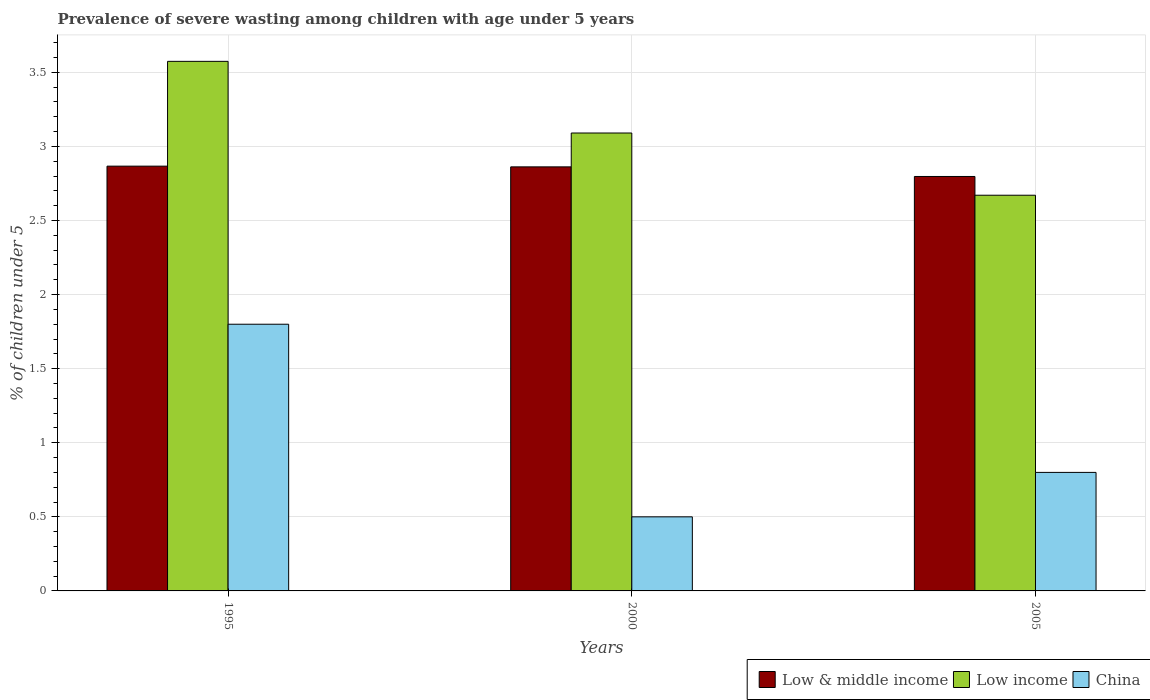How many different coloured bars are there?
Your answer should be very brief. 3. Are the number of bars per tick equal to the number of legend labels?
Give a very brief answer. Yes. Are the number of bars on each tick of the X-axis equal?
Offer a very short reply. Yes. What is the label of the 3rd group of bars from the left?
Offer a very short reply. 2005. What is the percentage of severely wasted children in China in 2005?
Give a very brief answer. 0.8. Across all years, what is the maximum percentage of severely wasted children in Low income?
Give a very brief answer. 3.57. Across all years, what is the minimum percentage of severely wasted children in Low & middle income?
Offer a very short reply. 2.8. What is the total percentage of severely wasted children in China in the graph?
Provide a short and direct response. 3.1. What is the difference between the percentage of severely wasted children in Low income in 1995 and that in 2005?
Your answer should be compact. 0.9. What is the difference between the percentage of severely wasted children in Low income in 2005 and the percentage of severely wasted children in Low & middle income in 1995?
Your response must be concise. -0.2. What is the average percentage of severely wasted children in Low & middle income per year?
Your answer should be compact. 2.84. In the year 1995, what is the difference between the percentage of severely wasted children in Low & middle income and percentage of severely wasted children in Low income?
Give a very brief answer. -0.71. In how many years, is the percentage of severely wasted children in Low income greater than 1.7 %?
Make the answer very short. 3. What is the ratio of the percentage of severely wasted children in China in 2000 to that in 2005?
Your answer should be very brief. 0.62. Is the percentage of severely wasted children in Low & middle income in 2000 less than that in 2005?
Keep it short and to the point. No. What is the difference between the highest and the second highest percentage of severely wasted children in Low & middle income?
Provide a short and direct response. 0. What is the difference between the highest and the lowest percentage of severely wasted children in Low & middle income?
Make the answer very short. 0.07. What does the 3rd bar from the left in 2005 represents?
Provide a succinct answer. China. Is it the case that in every year, the sum of the percentage of severely wasted children in Low & middle income and percentage of severely wasted children in Low income is greater than the percentage of severely wasted children in China?
Make the answer very short. Yes. Are the values on the major ticks of Y-axis written in scientific E-notation?
Your response must be concise. No. Does the graph contain any zero values?
Your response must be concise. No. Where does the legend appear in the graph?
Ensure brevity in your answer.  Bottom right. How many legend labels are there?
Offer a terse response. 3. What is the title of the graph?
Offer a very short reply. Prevalence of severe wasting among children with age under 5 years. Does "Norway" appear as one of the legend labels in the graph?
Keep it short and to the point. No. What is the label or title of the Y-axis?
Offer a very short reply. % of children under 5. What is the % of children under 5 in Low & middle income in 1995?
Your response must be concise. 2.87. What is the % of children under 5 of Low income in 1995?
Keep it short and to the point. 3.57. What is the % of children under 5 of China in 1995?
Give a very brief answer. 1.8. What is the % of children under 5 in Low & middle income in 2000?
Keep it short and to the point. 2.86. What is the % of children under 5 in Low income in 2000?
Keep it short and to the point. 3.09. What is the % of children under 5 in China in 2000?
Offer a terse response. 0.5. What is the % of children under 5 in Low & middle income in 2005?
Your answer should be compact. 2.8. What is the % of children under 5 in Low income in 2005?
Make the answer very short. 2.67. What is the % of children under 5 in China in 2005?
Keep it short and to the point. 0.8. Across all years, what is the maximum % of children under 5 of Low & middle income?
Offer a terse response. 2.87. Across all years, what is the maximum % of children under 5 of Low income?
Your answer should be very brief. 3.57. Across all years, what is the maximum % of children under 5 of China?
Provide a short and direct response. 1.8. Across all years, what is the minimum % of children under 5 in Low & middle income?
Your answer should be very brief. 2.8. Across all years, what is the minimum % of children under 5 of Low income?
Ensure brevity in your answer.  2.67. What is the total % of children under 5 of Low & middle income in the graph?
Ensure brevity in your answer.  8.53. What is the total % of children under 5 in Low income in the graph?
Offer a terse response. 9.34. What is the difference between the % of children under 5 in Low & middle income in 1995 and that in 2000?
Keep it short and to the point. 0. What is the difference between the % of children under 5 of Low income in 1995 and that in 2000?
Provide a succinct answer. 0.48. What is the difference between the % of children under 5 in China in 1995 and that in 2000?
Make the answer very short. 1.3. What is the difference between the % of children under 5 in Low & middle income in 1995 and that in 2005?
Offer a terse response. 0.07. What is the difference between the % of children under 5 of Low income in 1995 and that in 2005?
Your answer should be very brief. 0.9. What is the difference between the % of children under 5 of China in 1995 and that in 2005?
Your answer should be compact. 1. What is the difference between the % of children under 5 in Low & middle income in 2000 and that in 2005?
Provide a short and direct response. 0.06. What is the difference between the % of children under 5 in Low income in 2000 and that in 2005?
Your answer should be compact. 0.42. What is the difference between the % of children under 5 in Low & middle income in 1995 and the % of children under 5 in Low income in 2000?
Keep it short and to the point. -0.22. What is the difference between the % of children under 5 of Low & middle income in 1995 and the % of children under 5 of China in 2000?
Your answer should be very brief. 2.37. What is the difference between the % of children under 5 in Low income in 1995 and the % of children under 5 in China in 2000?
Provide a succinct answer. 3.07. What is the difference between the % of children under 5 in Low & middle income in 1995 and the % of children under 5 in Low income in 2005?
Ensure brevity in your answer.  0.2. What is the difference between the % of children under 5 in Low & middle income in 1995 and the % of children under 5 in China in 2005?
Your answer should be very brief. 2.07. What is the difference between the % of children under 5 of Low income in 1995 and the % of children under 5 of China in 2005?
Give a very brief answer. 2.77. What is the difference between the % of children under 5 of Low & middle income in 2000 and the % of children under 5 of Low income in 2005?
Ensure brevity in your answer.  0.19. What is the difference between the % of children under 5 of Low & middle income in 2000 and the % of children under 5 of China in 2005?
Your answer should be very brief. 2.06. What is the difference between the % of children under 5 in Low income in 2000 and the % of children under 5 in China in 2005?
Make the answer very short. 2.29. What is the average % of children under 5 in Low & middle income per year?
Provide a succinct answer. 2.84. What is the average % of children under 5 in Low income per year?
Your answer should be compact. 3.11. In the year 1995, what is the difference between the % of children under 5 of Low & middle income and % of children under 5 of Low income?
Your answer should be compact. -0.71. In the year 1995, what is the difference between the % of children under 5 in Low & middle income and % of children under 5 in China?
Make the answer very short. 1.07. In the year 1995, what is the difference between the % of children under 5 of Low income and % of children under 5 of China?
Make the answer very short. 1.77. In the year 2000, what is the difference between the % of children under 5 of Low & middle income and % of children under 5 of Low income?
Offer a very short reply. -0.23. In the year 2000, what is the difference between the % of children under 5 of Low & middle income and % of children under 5 of China?
Make the answer very short. 2.36. In the year 2000, what is the difference between the % of children under 5 of Low income and % of children under 5 of China?
Offer a terse response. 2.59. In the year 2005, what is the difference between the % of children under 5 of Low & middle income and % of children under 5 of Low income?
Offer a terse response. 0.13. In the year 2005, what is the difference between the % of children under 5 of Low & middle income and % of children under 5 of China?
Keep it short and to the point. 2. In the year 2005, what is the difference between the % of children under 5 of Low income and % of children under 5 of China?
Provide a short and direct response. 1.87. What is the ratio of the % of children under 5 of Low income in 1995 to that in 2000?
Keep it short and to the point. 1.16. What is the ratio of the % of children under 5 of China in 1995 to that in 2000?
Ensure brevity in your answer.  3.6. What is the ratio of the % of children under 5 of Low & middle income in 1995 to that in 2005?
Keep it short and to the point. 1.02. What is the ratio of the % of children under 5 of Low income in 1995 to that in 2005?
Your response must be concise. 1.34. What is the ratio of the % of children under 5 of China in 1995 to that in 2005?
Ensure brevity in your answer.  2.25. What is the ratio of the % of children under 5 in Low & middle income in 2000 to that in 2005?
Offer a terse response. 1.02. What is the ratio of the % of children under 5 of Low income in 2000 to that in 2005?
Give a very brief answer. 1.16. What is the ratio of the % of children under 5 of China in 2000 to that in 2005?
Offer a terse response. 0.62. What is the difference between the highest and the second highest % of children under 5 of Low & middle income?
Make the answer very short. 0. What is the difference between the highest and the second highest % of children under 5 in Low income?
Ensure brevity in your answer.  0.48. What is the difference between the highest and the second highest % of children under 5 of China?
Keep it short and to the point. 1. What is the difference between the highest and the lowest % of children under 5 of Low & middle income?
Provide a succinct answer. 0.07. What is the difference between the highest and the lowest % of children under 5 of Low income?
Your response must be concise. 0.9. What is the difference between the highest and the lowest % of children under 5 of China?
Provide a short and direct response. 1.3. 